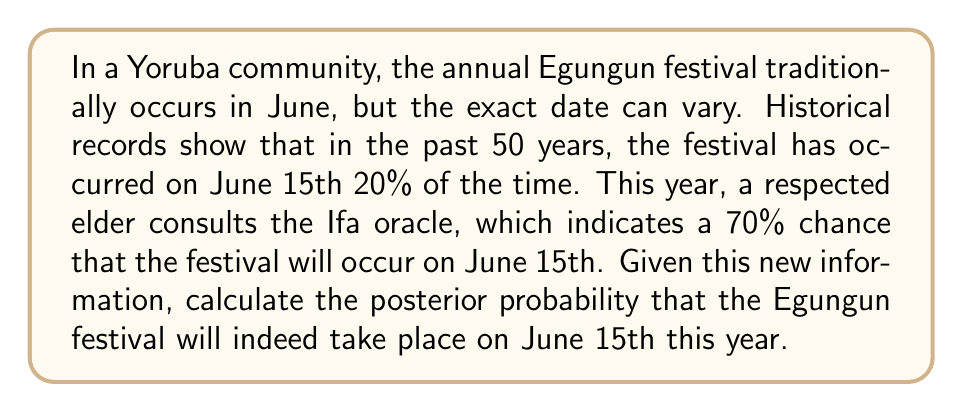Help me with this question. To solve this problem, we'll use Bayes' theorem:

$$ P(A|B) = \frac{P(B|A) \cdot P(A)}{P(B)} $$

Where:
A: The event that the festival occurs on June 15th
B: The oracle's prediction

We are given:
- P(A) = 0.20 (prior probability based on historical data)
- P(B|A) = 0.70 (likelihood of the oracle predicting June 15th given that it actually occurs on that date)

To calculate P(B), we use the law of total probability:

$$ P(B) = P(B|A) \cdot P(A) + P(B|\neg A) \cdot P(\neg A) $$

We need to determine P(B|¬A), which is the probability of the oracle predicting June 15th when the festival doesn't occur on that date. Let's assume the oracle has a false positive rate of 10%:

P(B|¬A) = 0.10

Now we can calculate P(B):

$$ P(B) = 0.70 \cdot 0.20 + 0.10 \cdot 0.80 = 0.14 + 0.08 = 0.22 $$

Using Bayes' theorem:

$$ P(A|B) = \frac{0.70 \cdot 0.20}{0.22} = \frac{0.14}{0.22} \approx 0.6364 $$
Answer: The posterior probability that the Egungun festival will occur on June 15th, given the oracle's prediction, is approximately 0.6364 or 63.64%. 